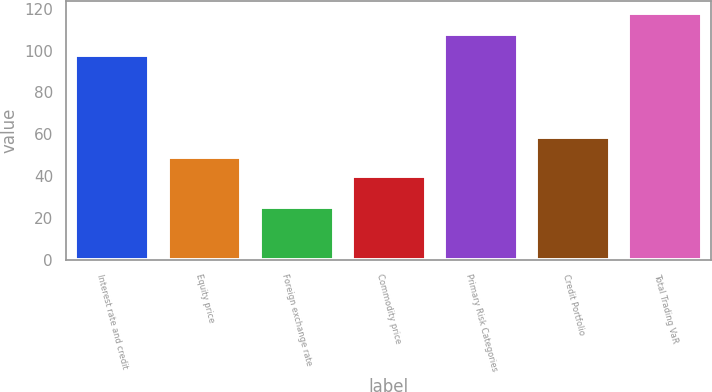Convert chart to OTSL. <chart><loc_0><loc_0><loc_500><loc_500><bar_chart><fcel>Interest rate and credit<fcel>Equity price<fcel>Foreign exchange rate<fcel>Commodity price<fcel>Primary Risk Categories<fcel>Credit Portfolio<fcel>Total Trading VaR<nl><fcel>98<fcel>49.3<fcel>25<fcel>40<fcel>108<fcel>58.6<fcel>118<nl></chart> 